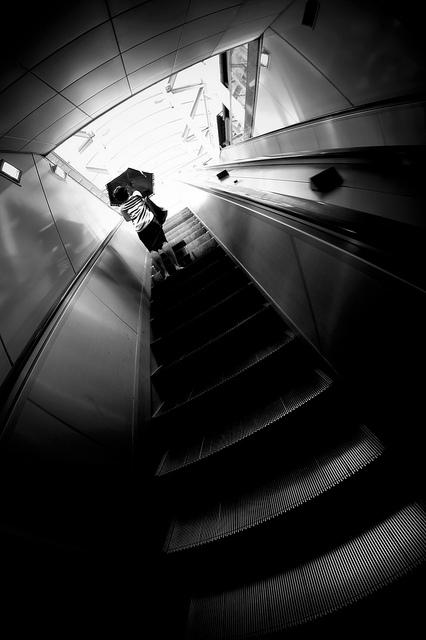Is the suitcase upside down?
Be succinct. No. Is there a shadow of the left handrail?
Be succinct. Yes. What is this indoor mode of transport called?
Concise answer only. Escalator. Are these stairs?
Answer briefly. Yes. Are these steps scary?
Be succinct. Yes. 